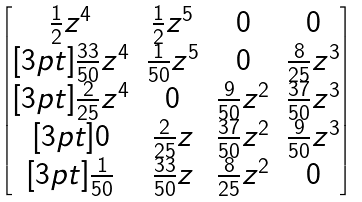Convert formula to latex. <formula><loc_0><loc_0><loc_500><loc_500>\begin{bmatrix} \frac { 1 } { 2 } z ^ { 4 } & \frac { 1 } { 2 } z ^ { 5 } & 0 & 0 \\ [ 3 p t ] \frac { 3 3 } { 5 0 } z ^ { 4 } & \frac { 1 } { 5 0 } z ^ { 5 } & 0 & \frac { 8 } { 2 5 } z ^ { 3 } \\ [ 3 p t ] \frac { 2 } { 2 5 } z ^ { 4 } & 0 & \frac { 9 } { 5 0 } z ^ { 2 } & \frac { 3 7 } { 5 0 } z ^ { 3 } \\ [ 3 p t ] 0 & \frac { 2 } { 2 5 } z & \frac { 3 7 } { 5 0 } z ^ { 2 } & \frac { 9 } { 5 0 } z ^ { 3 } \\ [ 3 p t ] \frac { 1 } { 5 0 } & \frac { 3 3 } { 5 0 } z & \frac { 8 } { 2 5 } z ^ { 2 } & 0 \end{bmatrix}</formula> 